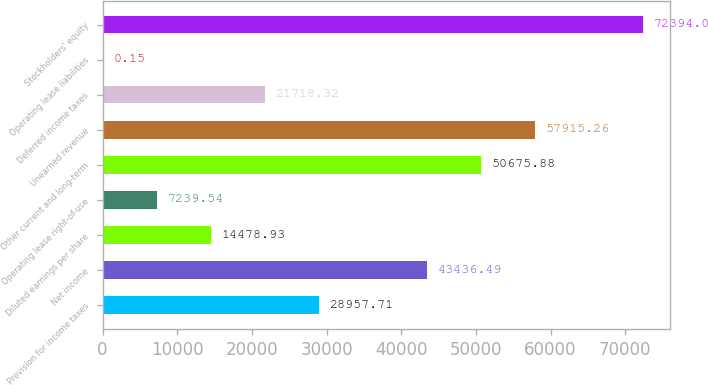Convert chart to OTSL. <chart><loc_0><loc_0><loc_500><loc_500><bar_chart><fcel>Provision for income taxes<fcel>Net income<fcel>Diluted earnings per share<fcel>Operating lease right-of-use<fcel>Other current and long-term<fcel>Unearned revenue<fcel>Deferred income taxes<fcel>Operating lease liabilities<fcel>Stockholders' equity<nl><fcel>28957.7<fcel>43436.5<fcel>14478.9<fcel>7239.54<fcel>50675.9<fcel>57915.3<fcel>21718.3<fcel>0.15<fcel>72394<nl></chart> 